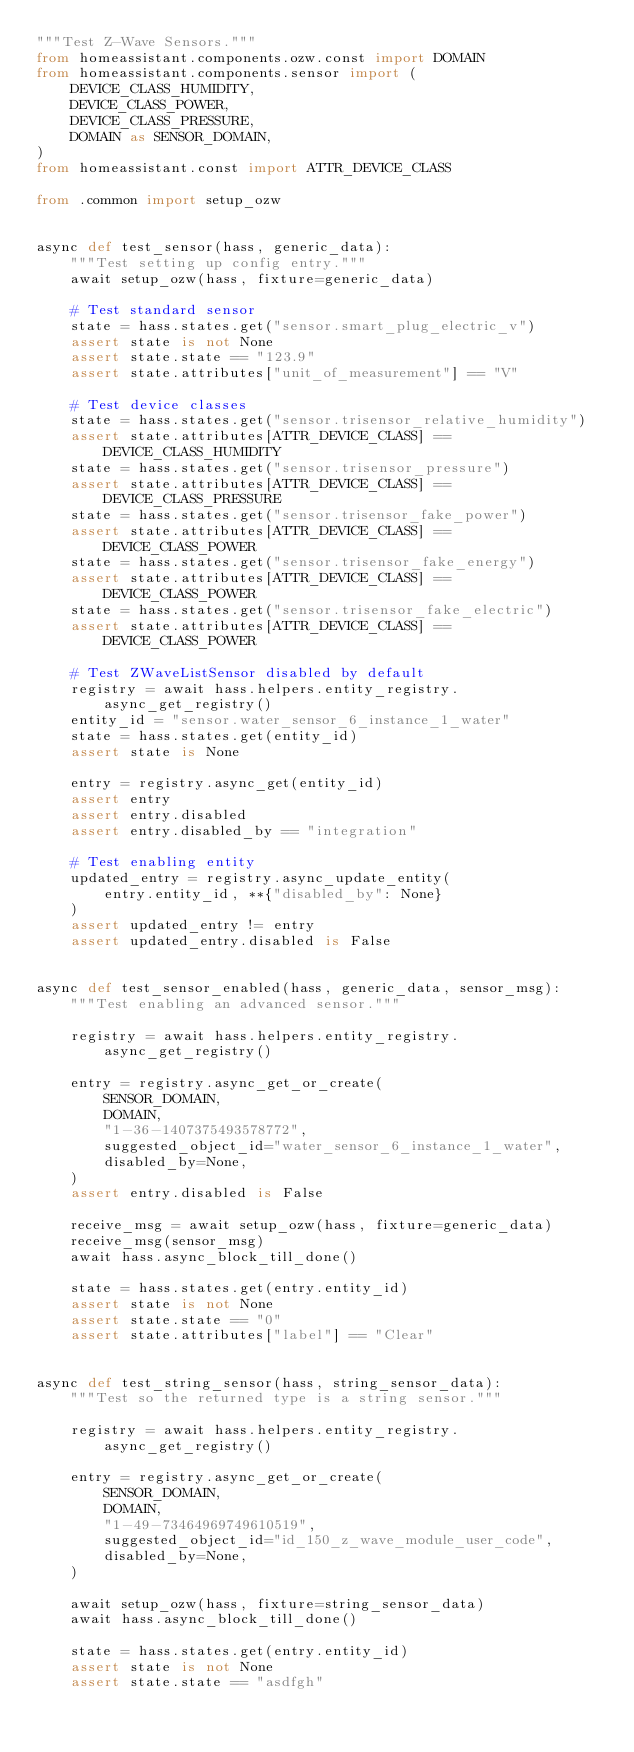<code> <loc_0><loc_0><loc_500><loc_500><_Python_>"""Test Z-Wave Sensors."""
from homeassistant.components.ozw.const import DOMAIN
from homeassistant.components.sensor import (
    DEVICE_CLASS_HUMIDITY,
    DEVICE_CLASS_POWER,
    DEVICE_CLASS_PRESSURE,
    DOMAIN as SENSOR_DOMAIN,
)
from homeassistant.const import ATTR_DEVICE_CLASS

from .common import setup_ozw


async def test_sensor(hass, generic_data):
    """Test setting up config entry."""
    await setup_ozw(hass, fixture=generic_data)

    # Test standard sensor
    state = hass.states.get("sensor.smart_plug_electric_v")
    assert state is not None
    assert state.state == "123.9"
    assert state.attributes["unit_of_measurement"] == "V"

    # Test device classes
    state = hass.states.get("sensor.trisensor_relative_humidity")
    assert state.attributes[ATTR_DEVICE_CLASS] == DEVICE_CLASS_HUMIDITY
    state = hass.states.get("sensor.trisensor_pressure")
    assert state.attributes[ATTR_DEVICE_CLASS] == DEVICE_CLASS_PRESSURE
    state = hass.states.get("sensor.trisensor_fake_power")
    assert state.attributes[ATTR_DEVICE_CLASS] == DEVICE_CLASS_POWER
    state = hass.states.get("sensor.trisensor_fake_energy")
    assert state.attributes[ATTR_DEVICE_CLASS] == DEVICE_CLASS_POWER
    state = hass.states.get("sensor.trisensor_fake_electric")
    assert state.attributes[ATTR_DEVICE_CLASS] == DEVICE_CLASS_POWER

    # Test ZWaveListSensor disabled by default
    registry = await hass.helpers.entity_registry.async_get_registry()
    entity_id = "sensor.water_sensor_6_instance_1_water"
    state = hass.states.get(entity_id)
    assert state is None

    entry = registry.async_get(entity_id)
    assert entry
    assert entry.disabled
    assert entry.disabled_by == "integration"

    # Test enabling entity
    updated_entry = registry.async_update_entity(
        entry.entity_id, **{"disabled_by": None}
    )
    assert updated_entry != entry
    assert updated_entry.disabled is False


async def test_sensor_enabled(hass, generic_data, sensor_msg):
    """Test enabling an advanced sensor."""

    registry = await hass.helpers.entity_registry.async_get_registry()

    entry = registry.async_get_or_create(
        SENSOR_DOMAIN,
        DOMAIN,
        "1-36-1407375493578772",
        suggested_object_id="water_sensor_6_instance_1_water",
        disabled_by=None,
    )
    assert entry.disabled is False

    receive_msg = await setup_ozw(hass, fixture=generic_data)
    receive_msg(sensor_msg)
    await hass.async_block_till_done()

    state = hass.states.get(entry.entity_id)
    assert state is not None
    assert state.state == "0"
    assert state.attributes["label"] == "Clear"


async def test_string_sensor(hass, string_sensor_data):
    """Test so the returned type is a string sensor."""

    registry = await hass.helpers.entity_registry.async_get_registry()

    entry = registry.async_get_or_create(
        SENSOR_DOMAIN,
        DOMAIN,
        "1-49-73464969749610519",
        suggested_object_id="id_150_z_wave_module_user_code",
        disabled_by=None,
    )

    await setup_ozw(hass, fixture=string_sensor_data)
    await hass.async_block_till_done()

    state = hass.states.get(entry.entity_id)
    assert state is not None
    assert state.state == "asdfgh"
</code> 